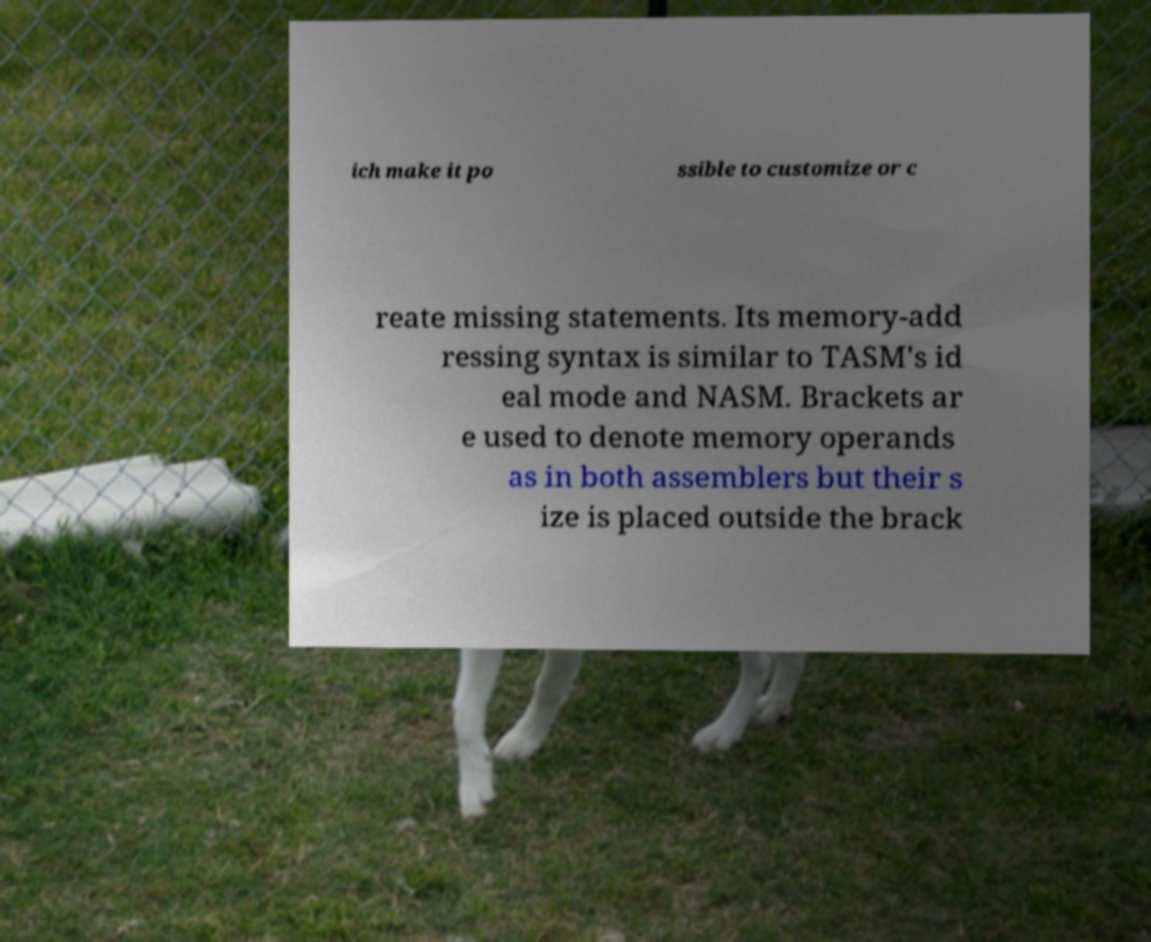For documentation purposes, I need the text within this image transcribed. Could you provide that? ich make it po ssible to customize or c reate missing statements. Its memory-add ressing syntax is similar to TASM's id eal mode and NASM. Brackets ar e used to denote memory operands as in both assemblers but their s ize is placed outside the brack 